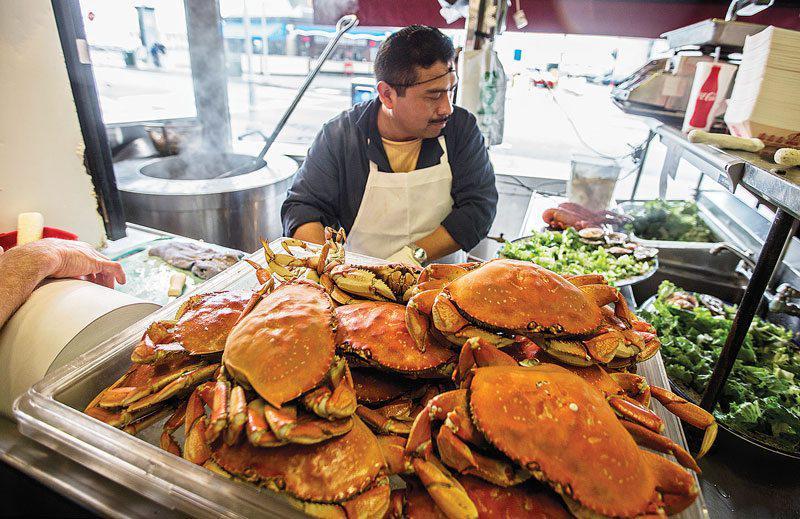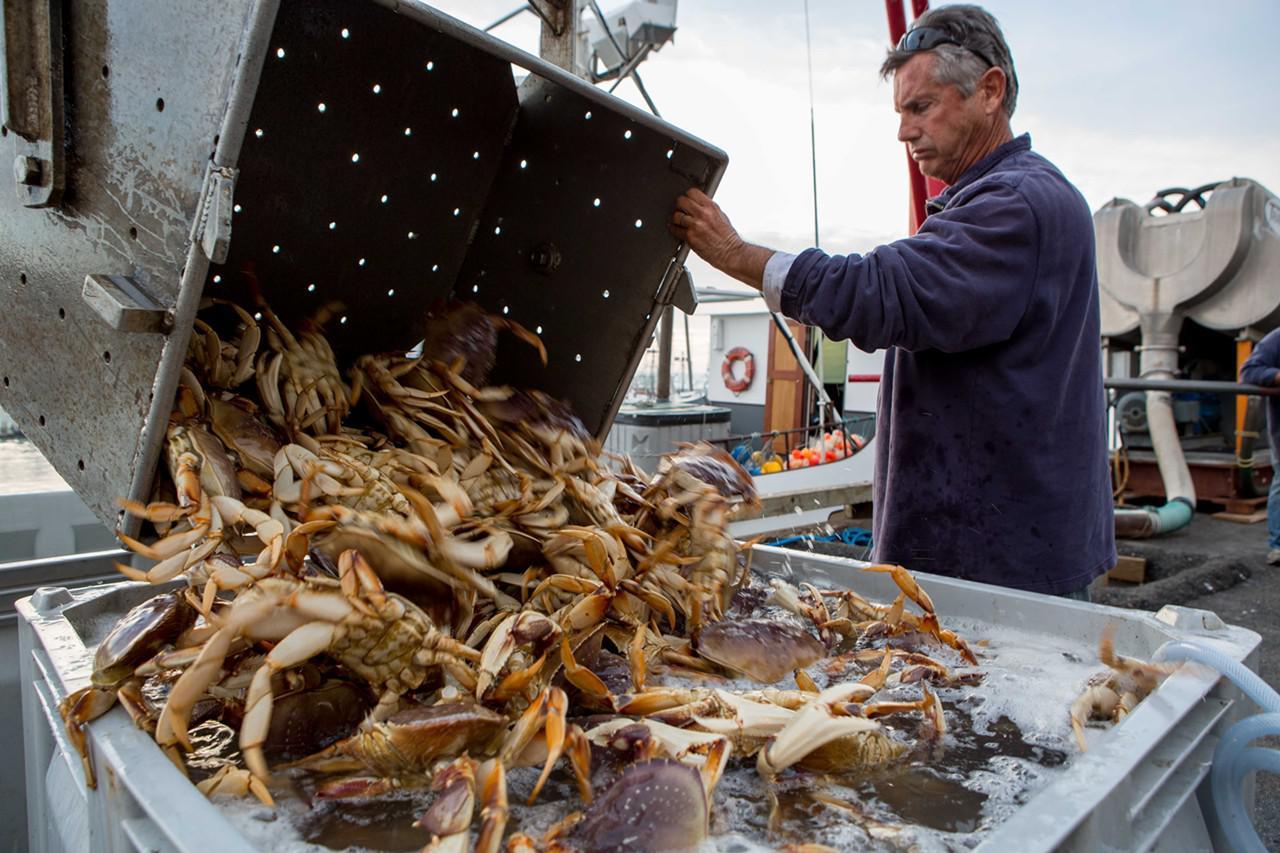The first image is the image on the left, the second image is the image on the right. Analyze the images presented: Is the assertion "A man is holding one of the crabs at chest height in one of the images." valid? Answer yes or no. No. The first image is the image on the left, the second image is the image on the right. Given the left and right images, does the statement "In the right image, a man is holding a crab up belly-side forward in one bare hand." hold true? Answer yes or no. No. 